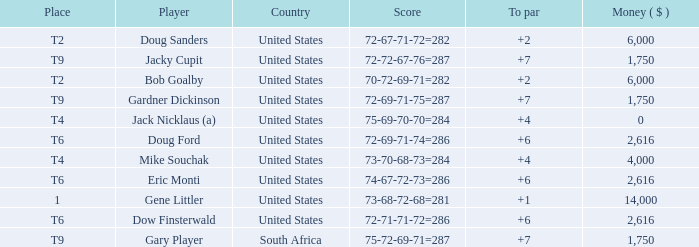What is the average To Par, when Score is "72-67-71-72=282"? 2.0. 